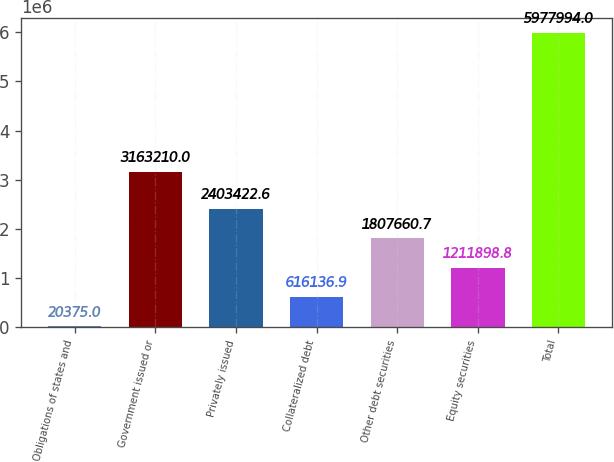Convert chart to OTSL. <chart><loc_0><loc_0><loc_500><loc_500><bar_chart><fcel>Obligations of states and<fcel>Government issued or<fcel>Privately issued<fcel>Collateralized debt<fcel>Other debt securities<fcel>Equity securities<fcel>Total<nl><fcel>20375<fcel>3.16321e+06<fcel>2.40342e+06<fcel>616137<fcel>1.80766e+06<fcel>1.2119e+06<fcel>5.97799e+06<nl></chart> 